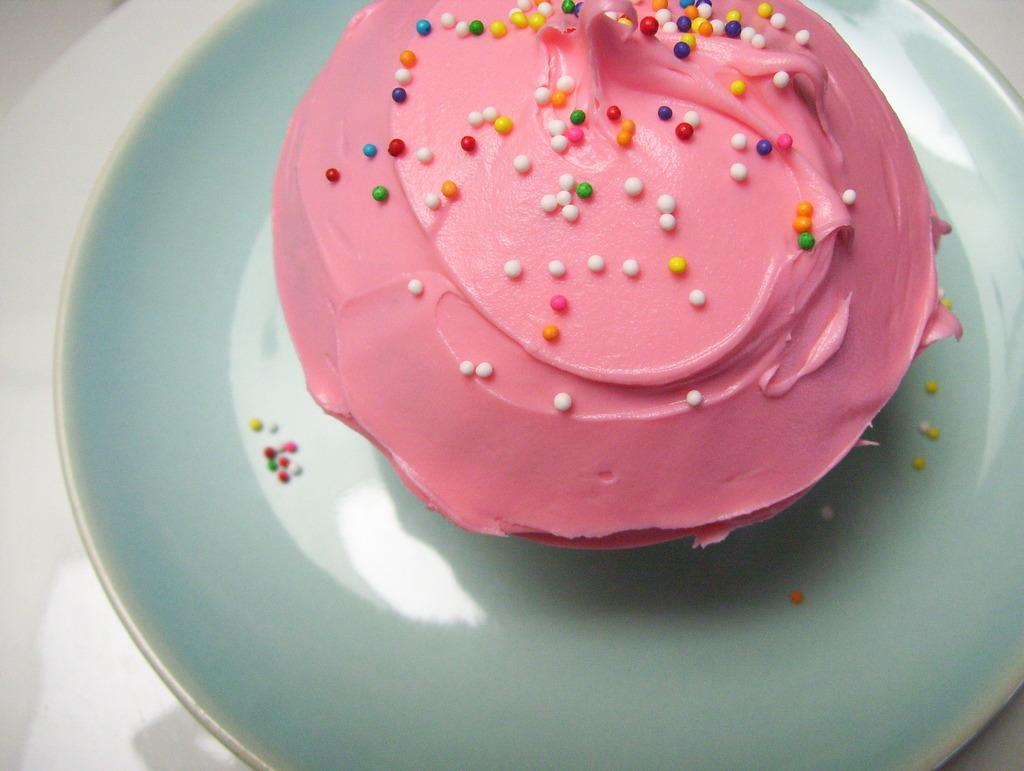What is the main subject of the image? The main subject of the image is a food item on a plate. Where is the plate with the food item located? The plate is placed on a table or an object in the image. What type of mist can be seen surrounding the food item in the image? There is no mist present in the image; it only shows a food item on a plate placed on a table or an object. 